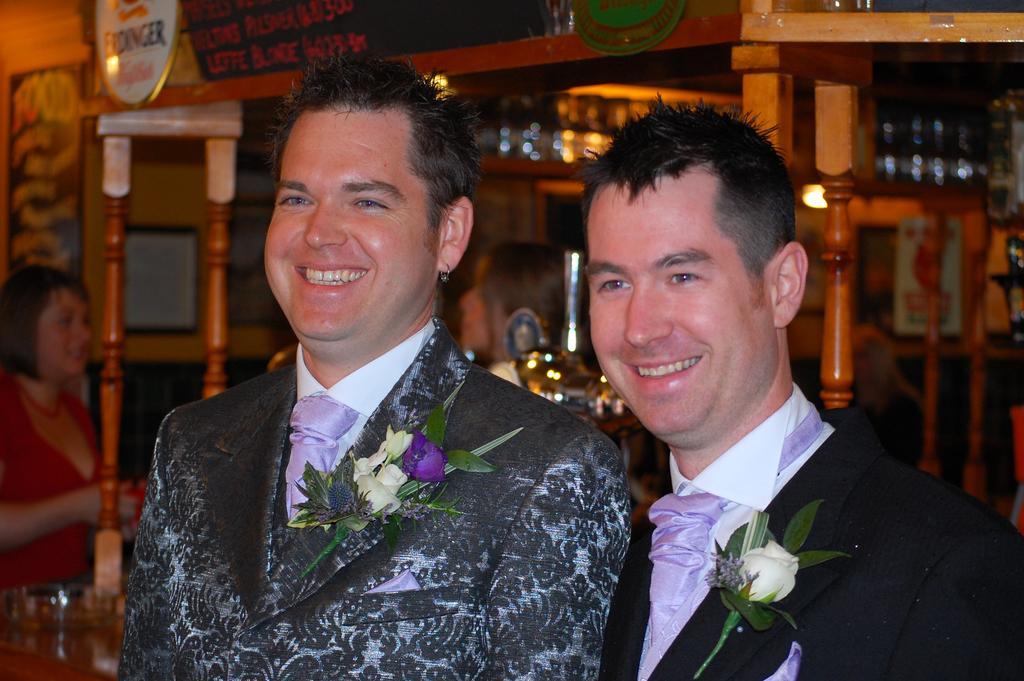How would you summarize this image in a sentence or two? In this picture we can observe two men wearing coats. Both of them were smiling. We can observe flowers on their coats. On the left side there is a woman standing. In the background there is a restaurant. 